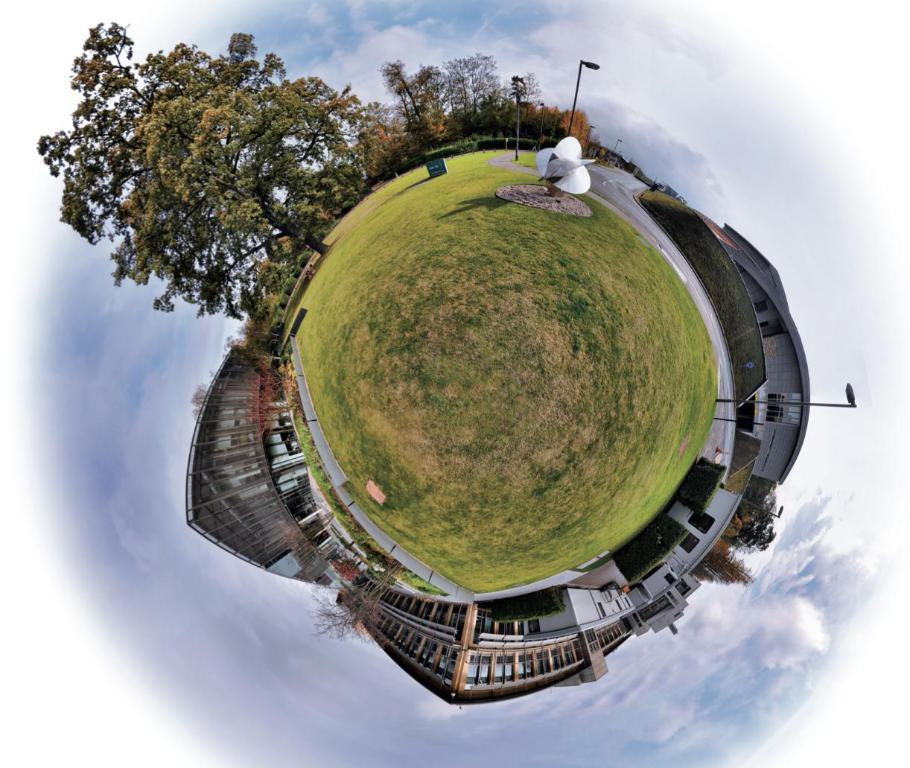What type of image is being shown? The image is a 360-degree picture. What can be seen in the image? There are many buildings and trees in the image. Can you describe the garden in the image? There is a sculpture in a garden in front of the buildings. What type of corn is being grown in the garden in the image? There is no corn visible in the image; there is a sculpture in the garden. What type of dress is the sculpture wearing in the image? The sculpture in the image is not a person, so it is not wearing a dress. 